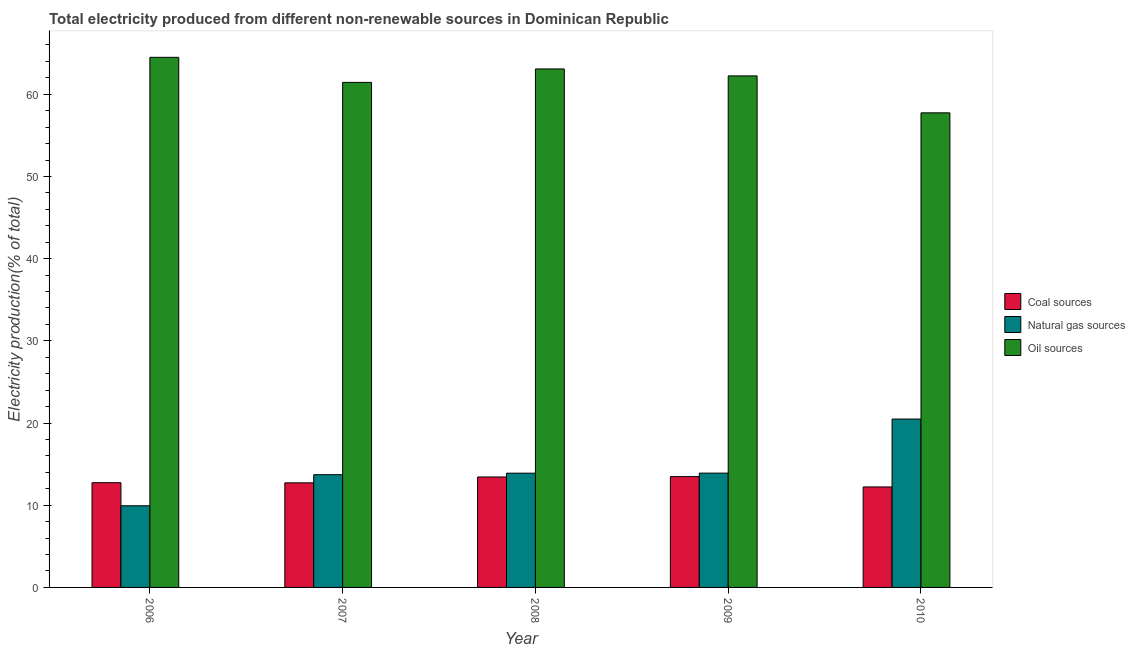How many different coloured bars are there?
Provide a short and direct response. 3. Are the number of bars per tick equal to the number of legend labels?
Your answer should be compact. Yes. Are the number of bars on each tick of the X-axis equal?
Provide a succinct answer. Yes. What is the label of the 2nd group of bars from the left?
Provide a short and direct response. 2007. What is the percentage of electricity produced by coal in 2007?
Your response must be concise. 12.73. Across all years, what is the maximum percentage of electricity produced by natural gas?
Offer a terse response. 20.49. Across all years, what is the minimum percentage of electricity produced by oil sources?
Ensure brevity in your answer.  57.74. What is the total percentage of electricity produced by coal in the graph?
Ensure brevity in your answer.  64.61. What is the difference between the percentage of electricity produced by natural gas in 2006 and that in 2008?
Provide a short and direct response. -3.96. What is the difference between the percentage of electricity produced by coal in 2007 and the percentage of electricity produced by natural gas in 2008?
Your response must be concise. -0.71. What is the average percentage of electricity produced by oil sources per year?
Offer a very short reply. 61.8. In the year 2007, what is the difference between the percentage of electricity produced by natural gas and percentage of electricity produced by coal?
Offer a terse response. 0. What is the ratio of the percentage of electricity produced by natural gas in 2007 to that in 2009?
Offer a very short reply. 0.99. Is the percentage of electricity produced by natural gas in 2008 less than that in 2010?
Offer a terse response. Yes. What is the difference between the highest and the second highest percentage of electricity produced by natural gas?
Make the answer very short. 6.58. What is the difference between the highest and the lowest percentage of electricity produced by natural gas?
Offer a very short reply. 10.55. Is the sum of the percentage of electricity produced by oil sources in 2006 and 2008 greater than the maximum percentage of electricity produced by coal across all years?
Your response must be concise. Yes. What does the 1st bar from the left in 2009 represents?
Ensure brevity in your answer.  Coal sources. What does the 1st bar from the right in 2007 represents?
Provide a short and direct response. Oil sources. Is it the case that in every year, the sum of the percentage of electricity produced by coal and percentage of electricity produced by natural gas is greater than the percentage of electricity produced by oil sources?
Offer a very short reply. No. Are all the bars in the graph horizontal?
Your response must be concise. No. How many years are there in the graph?
Keep it short and to the point. 5. What is the difference between two consecutive major ticks on the Y-axis?
Your answer should be compact. 10. Are the values on the major ticks of Y-axis written in scientific E-notation?
Give a very brief answer. No. Where does the legend appear in the graph?
Offer a terse response. Center right. How many legend labels are there?
Provide a succinct answer. 3. What is the title of the graph?
Ensure brevity in your answer.  Total electricity produced from different non-renewable sources in Dominican Republic. Does "Social insurance" appear as one of the legend labels in the graph?
Give a very brief answer. No. What is the label or title of the X-axis?
Your response must be concise. Year. What is the Electricity production(% of total) of Coal sources in 2006?
Your answer should be very brief. 12.74. What is the Electricity production(% of total) in Natural gas sources in 2006?
Make the answer very short. 9.94. What is the Electricity production(% of total) in Oil sources in 2006?
Provide a succinct answer. 64.49. What is the Electricity production(% of total) of Coal sources in 2007?
Give a very brief answer. 12.73. What is the Electricity production(% of total) of Natural gas sources in 2007?
Make the answer very short. 13.72. What is the Electricity production(% of total) of Oil sources in 2007?
Provide a short and direct response. 61.45. What is the Electricity production(% of total) of Coal sources in 2008?
Provide a short and direct response. 13.44. What is the Electricity production(% of total) in Natural gas sources in 2008?
Offer a terse response. 13.9. What is the Electricity production(% of total) of Oil sources in 2008?
Provide a short and direct response. 63.08. What is the Electricity production(% of total) in Coal sources in 2009?
Provide a succinct answer. 13.48. What is the Electricity production(% of total) in Natural gas sources in 2009?
Provide a succinct answer. 13.91. What is the Electricity production(% of total) of Oil sources in 2009?
Your answer should be compact. 62.23. What is the Electricity production(% of total) of Coal sources in 2010?
Make the answer very short. 12.22. What is the Electricity production(% of total) in Natural gas sources in 2010?
Make the answer very short. 20.49. What is the Electricity production(% of total) of Oil sources in 2010?
Your answer should be compact. 57.74. Across all years, what is the maximum Electricity production(% of total) of Coal sources?
Your response must be concise. 13.48. Across all years, what is the maximum Electricity production(% of total) in Natural gas sources?
Your response must be concise. 20.49. Across all years, what is the maximum Electricity production(% of total) in Oil sources?
Make the answer very short. 64.49. Across all years, what is the minimum Electricity production(% of total) in Coal sources?
Keep it short and to the point. 12.22. Across all years, what is the minimum Electricity production(% of total) of Natural gas sources?
Keep it short and to the point. 9.94. Across all years, what is the minimum Electricity production(% of total) in Oil sources?
Provide a succinct answer. 57.74. What is the total Electricity production(% of total) in Coal sources in the graph?
Offer a terse response. 64.61. What is the total Electricity production(% of total) in Natural gas sources in the graph?
Make the answer very short. 71.94. What is the total Electricity production(% of total) of Oil sources in the graph?
Give a very brief answer. 309. What is the difference between the Electricity production(% of total) of Coal sources in 2006 and that in 2007?
Keep it short and to the point. 0.02. What is the difference between the Electricity production(% of total) in Natural gas sources in 2006 and that in 2007?
Your response must be concise. -3.78. What is the difference between the Electricity production(% of total) of Oil sources in 2006 and that in 2007?
Offer a very short reply. 3.05. What is the difference between the Electricity production(% of total) of Coal sources in 2006 and that in 2008?
Make the answer very short. -0.7. What is the difference between the Electricity production(% of total) of Natural gas sources in 2006 and that in 2008?
Provide a short and direct response. -3.96. What is the difference between the Electricity production(% of total) in Oil sources in 2006 and that in 2008?
Give a very brief answer. 1.41. What is the difference between the Electricity production(% of total) of Coal sources in 2006 and that in 2009?
Offer a terse response. -0.74. What is the difference between the Electricity production(% of total) of Natural gas sources in 2006 and that in 2009?
Your answer should be very brief. -3.97. What is the difference between the Electricity production(% of total) of Oil sources in 2006 and that in 2009?
Keep it short and to the point. 2.26. What is the difference between the Electricity production(% of total) of Coal sources in 2006 and that in 2010?
Provide a short and direct response. 0.52. What is the difference between the Electricity production(% of total) of Natural gas sources in 2006 and that in 2010?
Provide a short and direct response. -10.55. What is the difference between the Electricity production(% of total) in Oil sources in 2006 and that in 2010?
Keep it short and to the point. 6.75. What is the difference between the Electricity production(% of total) in Coal sources in 2007 and that in 2008?
Provide a short and direct response. -0.71. What is the difference between the Electricity production(% of total) in Natural gas sources in 2007 and that in 2008?
Offer a terse response. -0.18. What is the difference between the Electricity production(% of total) of Oil sources in 2007 and that in 2008?
Provide a succinct answer. -1.64. What is the difference between the Electricity production(% of total) of Coal sources in 2007 and that in 2009?
Offer a very short reply. -0.76. What is the difference between the Electricity production(% of total) of Natural gas sources in 2007 and that in 2009?
Make the answer very short. -0.19. What is the difference between the Electricity production(% of total) in Oil sources in 2007 and that in 2009?
Keep it short and to the point. -0.79. What is the difference between the Electricity production(% of total) of Coal sources in 2007 and that in 2010?
Your response must be concise. 0.5. What is the difference between the Electricity production(% of total) of Natural gas sources in 2007 and that in 2010?
Give a very brief answer. -6.77. What is the difference between the Electricity production(% of total) in Oil sources in 2007 and that in 2010?
Your answer should be very brief. 3.7. What is the difference between the Electricity production(% of total) in Coal sources in 2008 and that in 2009?
Offer a very short reply. -0.04. What is the difference between the Electricity production(% of total) of Natural gas sources in 2008 and that in 2009?
Provide a succinct answer. -0.01. What is the difference between the Electricity production(% of total) in Oil sources in 2008 and that in 2009?
Provide a succinct answer. 0.85. What is the difference between the Electricity production(% of total) of Coal sources in 2008 and that in 2010?
Provide a short and direct response. 1.22. What is the difference between the Electricity production(% of total) of Natural gas sources in 2008 and that in 2010?
Offer a terse response. -6.59. What is the difference between the Electricity production(% of total) of Oil sources in 2008 and that in 2010?
Provide a short and direct response. 5.34. What is the difference between the Electricity production(% of total) of Coal sources in 2009 and that in 2010?
Provide a succinct answer. 1.26. What is the difference between the Electricity production(% of total) of Natural gas sources in 2009 and that in 2010?
Ensure brevity in your answer.  -6.58. What is the difference between the Electricity production(% of total) in Oil sources in 2009 and that in 2010?
Provide a succinct answer. 4.49. What is the difference between the Electricity production(% of total) in Coal sources in 2006 and the Electricity production(% of total) in Natural gas sources in 2007?
Provide a succinct answer. -0.97. What is the difference between the Electricity production(% of total) of Coal sources in 2006 and the Electricity production(% of total) of Oil sources in 2007?
Offer a very short reply. -48.71. What is the difference between the Electricity production(% of total) of Natural gas sources in 2006 and the Electricity production(% of total) of Oil sources in 2007?
Give a very brief answer. -51.51. What is the difference between the Electricity production(% of total) of Coal sources in 2006 and the Electricity production(% of total) of Natural gas sources in 2008?
Offer a terse response. -1.16. What is the difference between the Electricity production(% of total) in Coal sources in 2006 and the Electricity production(% of total) in Oil sources in 2008?
Your answer should be very brief. -50.34. What is the difference between the Electricity production(% of total) of Natural gas sources in 2006 and the Electricity production(% of total) of Oil sources in 2008?
Your answer should be very brief. -53.15. What is the difference between the Electricity production(% of total) of Coal sources in 2006 and the Electricity production(% of total) of Natural gas sources in 2009?
Keep it short and to the point. -1.17. What is the difference between the Electricity production(% of total) of Coal sources in 2006 and the Electricity production(% of total) of Oil sources in 2009?
Your answer should be very brief. -49.49. What is the difference between the Electricity production(% of total) of Natural gas sources in 2006 and the Electricity production(% of total) of Oil sources in 2009?
Provide a succinct answer. -52.3. What is the difference between the Electricity production(% of total) in Coal sources in 2006 and the Electricity production(% of total) in Natural gas sources in 2010?
Make the answer very short. -7.74. What is the difference between the Electricity production(% of total) of Coal sources in 2006 and the Electricity production(% of total) of Oil sources in 2010?
Provide a succinct answer. -45. What is the difference between the Electricity production(% of total) of Natural gas sources in 2006 and the Electricity production(% of total) of Oil sources in 2010?
Give a very brief answer. -47.81. What is the difference between the Electricity production(% of total) of Coal sources in 2007 and the Electricity production(% of total) of Natural gas sources in 2008?
Give a very brief answer. -1.17. What is the difference between the Electricity production(% of total) of Coal sources in 2007 and the Electricity production(% of total) of Oil sources in 2008?
Provide a succinct answer. -50.36. What is the difference between the Electricity production(% of total) in Natural gas sources in 2007 and the Electricity production(% of total) in Oil sources in 2008?
Your answer should be compact. -49.37. What is the difference between the Electricity production(% of total) of Coal sources in 2007 and the Electricity production(% of total) of Natural gas sources in 2009?
Provide a short and direct response. -1.18. What is the difference between the Electricity production(% of total) of Coal sources in 2007 and the Electricity production(% of total) of Oil sources in 2009?
Offer a terse response. -49.51. What is the difference between the Electricity production(% of total) of Natural gas sources in 2007 and the Electricity production(% of total) of Oil sources in 2009?
Offer a very short reply. -48.52. What is the difference between the Electricity production(% of total) in Coal sources in 2007 and the Electricity production(% of total) in Natural gas sources in 2010?
Give a very brief answer. -7.76. What is the difference between the Electricity production(% of total) in Coal sources in 2007 and the Electricity production(% of total) in Oil sources in 2010?
Your answer should be compact. -45.02. What is the difference between the Electricity production(% of total) of Natural gas sources in 2007 and the Electricity production(% of total) of Oil sources in 2010?
Offer a very short reply. -44.03. What is the difference between the Electricity production(% of total) of Coal sources in 2008 and the Electricity production(% of total) of Natural gas sources in 2009?
Provide a short and direct response. -0.47. What is the difference between the Electricity production(% of total) of Coal sources in 2008 and the Electricity production(% of total) of Oil sources in 2009?
Offer a terse response. -48.8. What is the difference between the Electricity production(% of total) of Natural gas sources in 2008 and the Electricity production(% of total) of Oil sources in 2009?
Make the answer very short. -48.34. What is the difference between the Electricity production(% of total) in Coal sources in 2008 and the Electricity production(% of total) in Natural gas sources in 2010?
Ensure brevity in your answer.  -7.05. What is the difference between the Electricity production(% of total) of Coal sources in 2008 and the Electricity production(% of total) of Oil sources in 2010?
Offer a very short reply. -44.3. What is the difference between the Electricity production(% of total) of Natural gas sources in 2008 and the Electricity production(% of total) of Oil sources in 2010?
Give a very brief answer. -43.84. What is the difference between the Electricity production(% of total) of Coal sources in 2009 and the Electricity production(% of total) of Natural gas sources in 2010?
Offer a very short reply. -7. What is the difference between the Electricity production(% of total) of Coal sources in 2009 and the Electricity production(% of total) of Oil sources in 2010?
Offer a very short reply. -44.26. What is the difference between the Electricity production(% of total) of Natural gas sources in 2009 and the Electricity production(% of total) of Oil sources in 2010?
Provide a short and direct response. -43.83. What is the average Electricity production(% of total) in Coal sources per year?
Make the answer very short. 12.92. What is the average Electricity production(% of total) of Natural gas sources per year?
Provide a succinct answer. 14.39. What is the average Electricity production(% of total) of Oil sources per year?
Offer a very short reply. 61.8. In the year 2006, what is the difference between the Electricity production(% of total) in Coal sources and Electricity production(% of total) in Natural gas sources?
Make the answer very short. 2.81. In the year 2006, what is the difference between the Electricity production(% of total) of Coal sources and Electricity production(% of total) of Oil sources?
Provide a succinct answer. -51.75. In the year 2006, what is the difference between the Electricity production(% of total) in Natural gas sources and Electricity production(% of total) in Oil sources?
Your answer should be compact. -54.56. In the year 2007, what is the difference between the Electricity production(% of total) in Coal sources and Electricity production(% of total) in Natural gas sources?
Your response must be concise. -0.99. In the year 2007, what is the difference between the Electricity production(% of total) of Coal sources and Electricity production(% of total) of Oil sources?
Offer a terse response. -48.72. In the year 2007, what is the difference between the Electricity production(% of total) of Natural gas sources and Electricity production(% of total) of Oil sources?
Your response must be concise. -47.73. In the year 2008, what is the difference between the Electricity production(% of total) in Coal sources and Electricity production(% of total) in Natural gas sources?
Provide a succinct answer. -0.46. In the year 2008, what is the difference between the Electricity production(% of total) in Coal sources and Electricity production(% of total) in Oil sources?
Provide a short and direct response. -49.64. In the year 2008, what is the difference between the Electricity production(% of total) of Natural gas sources and Electricity production(% of total) of Oil sources?
Make the answer very short. -49.18. In the year 2009, what is the difference between the Electricity production(% of total) in Coal sources and Electricity production(% of total) in Natural gas sources?
Your answer should be very brief. -0.42. In the year 2009, what is the difference between the Electricity production(% of total) of Coal sources and Electricity production(% of total) of Oil sources?
Your response must be concise. -48.75. In the year 2009, what is the difference between the Electricity production(% of total) of Natural gas sources and Electricity production(% of total) of Oil sources?
Your answer should be very brief. -48.33. In the year 2010, what is the difference between the Electricity production(% of total) in Coal sources and Electricity production(% of total) in Natural gas sources?
Your response must be concise. -8.26. In the year 2010, what is the difference between the Electricity production(% of total) of Coal sources and Electricity production(% of total) of Oil sources?
Ensure brevity in your answer.  -45.52. In the year 2010, what is the difference between the Electricity production(% of total) in Natural gas sources and Electricity production(% of total) in Oil sources?
Your answer should be compact. -37.26. What is the ratio of the Electricity production(% of total) of Coal sources in 2006 to that in 2007?
Offer a terse response. 1. What is the ratio of the Electricity production(% of total) in Natural gas sources in 2006 to that in 2007?
Provide a short and direct response. 0.72. What is the ratio of the Electricity production(% of total) in Oil sources in 2006 to that in 2007?
Make the answer very short. 1.05. What is the ratio of the Electricity production(% of total) of Coal sources in 2006 to that in 2008?
Provide a short and direct response. 0.95. What is the ratio of the Electricity production(% of total) in Natural gas sources in 2006 to that in 2008?
Your response must be concise. 0.71. What is the ratio of the Electricity production(% of total) of Oil sources in 2006 to that in 2008?
Your answer should be compact. 1.02. What is the ratio of the Electricity production(% of total) of Coal sources in 2006 to that in 2009?
Offer a terse response. 0.94. What is the ratio of the Electricity production(% of total) in Natural gas sources in 2006 to that in 2009?
Give a very brief answer. 0.71. What is the ratio of the Electricity production(% of total) of Oil sources in 2006 to that in 2009?
Offer a very short reply. 1.04. What is the ratio of the Electricity production(% of total) in Coal sources in 2006 to that in 2010?
Offer a very short reply. 1.04. What is the ratio of the Electricity production(% of total) in Natural gas sources in 2006 to that in 2010?
Your response must be concise. 0.48. What is the ratio of the Electricity production(% of total) in Oil sources in 2006 to that in 2010?
Offer a terse response. 1.12. What is the ratio of the Electricity production(% of total) of Coal sources in 2007 to that in 2008?
Offer a very short reply. 0.95. What is the ratio of the Electricity production(% of total) in Natural gas sources in 2007 to that in 2008?
Your response must be concise. 0.99. What is the ratio of the Electricity production(% of total) of Oil sources in 2007 to that in 2008?
Your answer should be compact. 0.97. What is the ratio of the Electricity production(% of total) in Coal sources in 2007 to that in 2009?
Make the answer very short. 0.94. What is the ratio of the Electricity production(% of total) in Natural gas sources in 2007 to that in 2009?
Make the answer very short. 0.99. What is the ratio of the Electricity production(% of total) of Oil sources in 2007 to that in 2009?
Your response must be concise. 0.99. What is the ratio of the Electricity production(% of total) in Coal sources in 2007 to that in 2010?
Provide a succinct answer. 1.04. What is the ratio of the Electricity production(% of total) of Natural gas sources in 2007 to that in 2010?
Give a very brief answer. 0.67. What is the ratio of the Electricity production(% of total) in Oil sources in 2007 to that in 2010?
Your answer should be very brief. 1.06. What is the ratio of the Electricity production(% of total) of Oil sources in 2008 to that in 2009?
Offer a terse response. 1.01. What is the ratio of the Electricity production(% of total) in Coal sources in 2008 to that in 2010?
Keep it short and to the point. 1.1. What is the ratio of the Electricity production(% of total) in Natural gas sources in 2008 to that in 2010?
Keep it short and to the point. 0.68. What is the ratio of the Electricity production(% of total) of Oil sources in 2008 to that in 2010?
Provide a short and direct response. 1.09. What is the ratio of the Electricity production(% of total) in Coal sources in 2009 to that in 2010?
Provide a short and direct response. 1.1. What is the ratio of the Electricity production(% of total) in Natural gas sources in 2009 to that in 2010?
Ensure brevity in your answer.  0.68. What is the ratio of the Electricity production(% of total) in Oil sources in 2009 to that in 2010?
Your answer should be compact. 1.08. What is the difference between the highest and the second highest Electricity production(% of total) of Coal sources?
Offer a terse response. 0.04. What is the difference between the highest and the second highest Electricity production(% of total) in Natural gas sources?
Give a very brief answer. 6.58. What is the difference between the highest and the second highest Electricity production(% of total) in Oil sources?
Offer a terse response. 1.41. What is the difference between the highest and the lowest Electricity production(% of total) of Coal sources?
Provide a short and direct response. 1.26. What is the difference between the highest and the lowest Electricity production(% of total) in Natural gas sources?
Your response must be concise. 10.55. What is the difference between the highest and the lowest Electricity production(% of total) of Oil sources?
Your response must be concise. 6.75. 